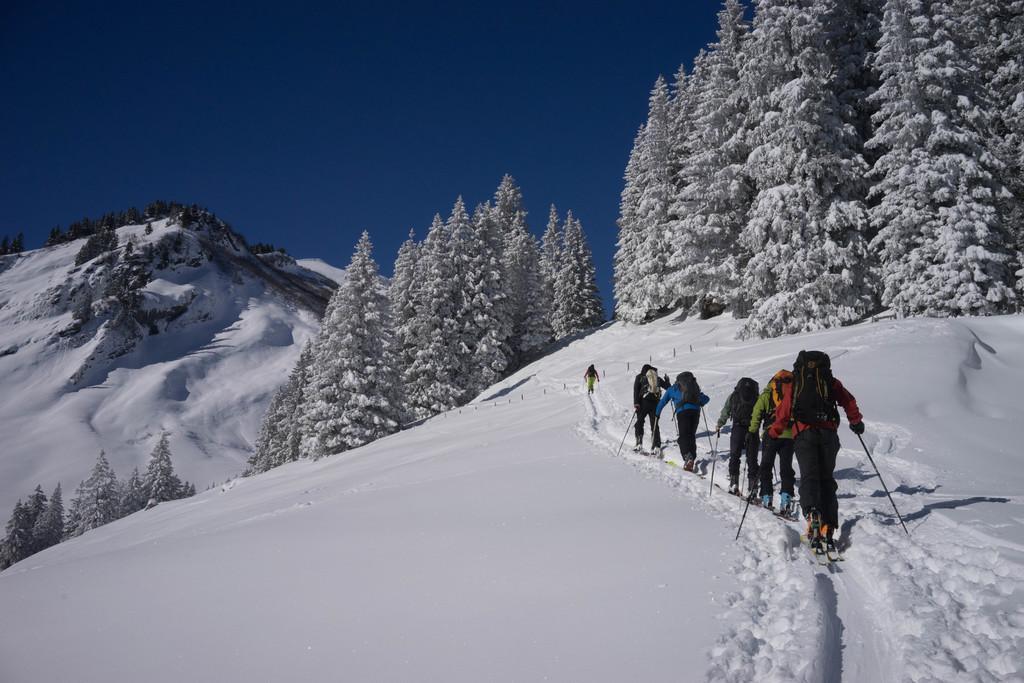Could you give a brief overview of what you see in this image? In this image few persons are walking on the snow. They are carrying bags. They are holding sticks in their hands. Right side there are few trees which are covered with snow. Left side there is a hill covered with snow. Top of the image there is sky. 